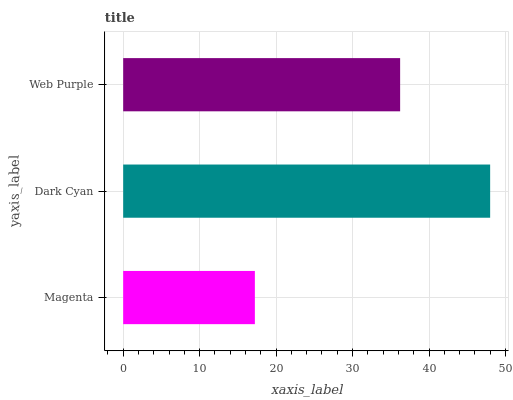Is Magenta the minimum?
Answer yes or no. Yes. Is Dark Cyan the maximum?
Answer yes or no. Yes. Is Web Purple the minimum?
Answer yes or no. No. Is Web Purple the maximum?
Answer yes or no. No. Is Dark Cyan greater than Web Purple?
Answer yes or no. Yes. Is Web Purple less than Dark Cyan?
Answer yes or no. Yes. Is Web Purple greater than Dark Cyan?
Answer yes or no. No. Is Dark Cyan less than Web Purple?
Answer yes or no. No. Is Web Purple the high median?
Answer yes or no. Yes. Is Web Purple the low median?
Answer yes or no. Yes. Is Dark Cyan the high median?
Answer yes or no. No. Is Dark Cyan the low median?
Answer yes or no. No. 